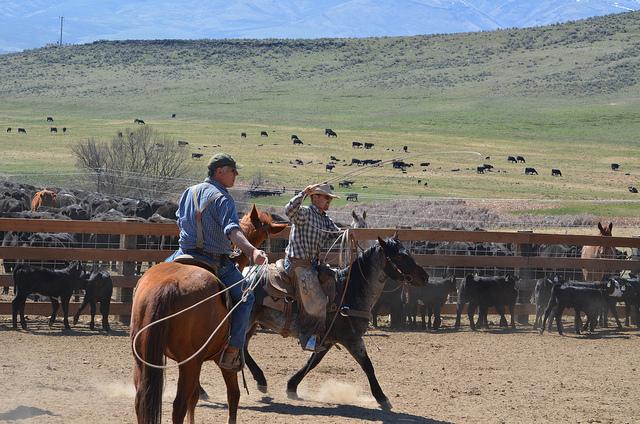Is this a rodeo?
Short answer required. No. Does the tree have leaves?
Answer briefly. No. Are the animals in their natural habitat?
Be succinct. No. Are both men holding a lasso?
Write a very short answer. Yes. How many people do you see?
Quick response, please. 2. How many men have on hats?
Give a very brief answer. 2. How many riders are mounted on these horses?
Concise answer only. 2. Where are they tethered?
Quick response, please. Fence. 